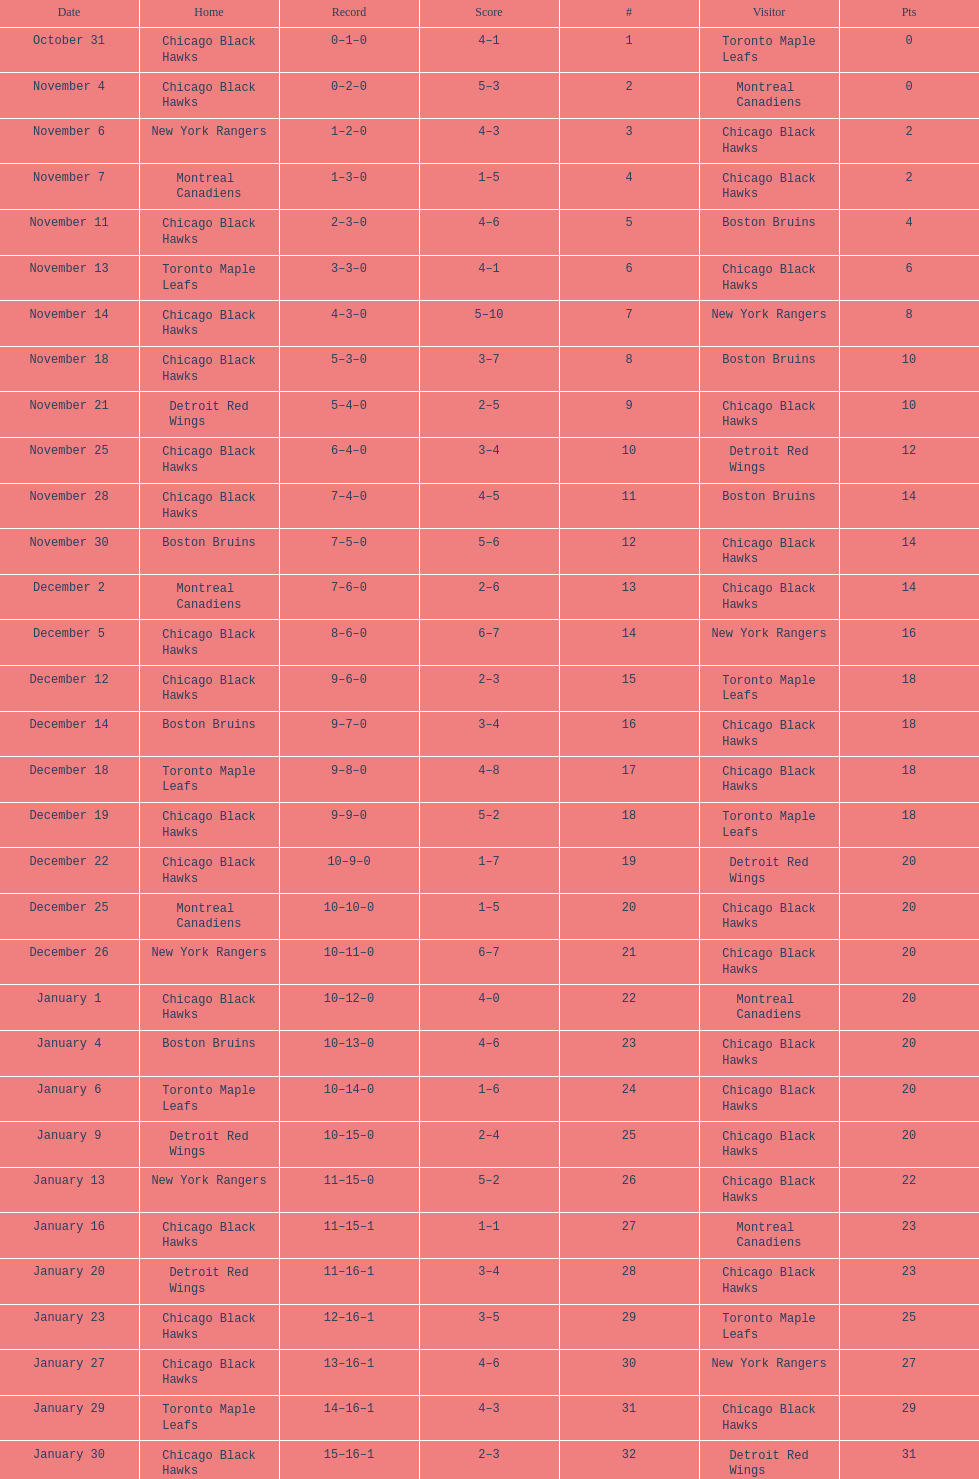What was the total amount of points scored on november 4th? 8. 